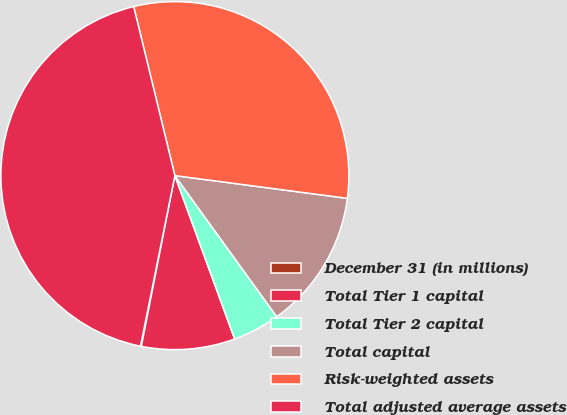<chart> <loc_0><loc_0><loc_500><loc_500><pie_chart><fcel>December 31 (in millions)<fcel>Total Tier 1 capital<fcel>Total Tier 2 capital<fcel>Total capital<fcel>Risk-weighted assets<fcel>Total adjusted average assets<nl><fcel>0.08%<fcel>8.67%<fcel>4.37%<fcel>12.96%<fcel>30.89%<fcel>43.03%<nl></chart> 